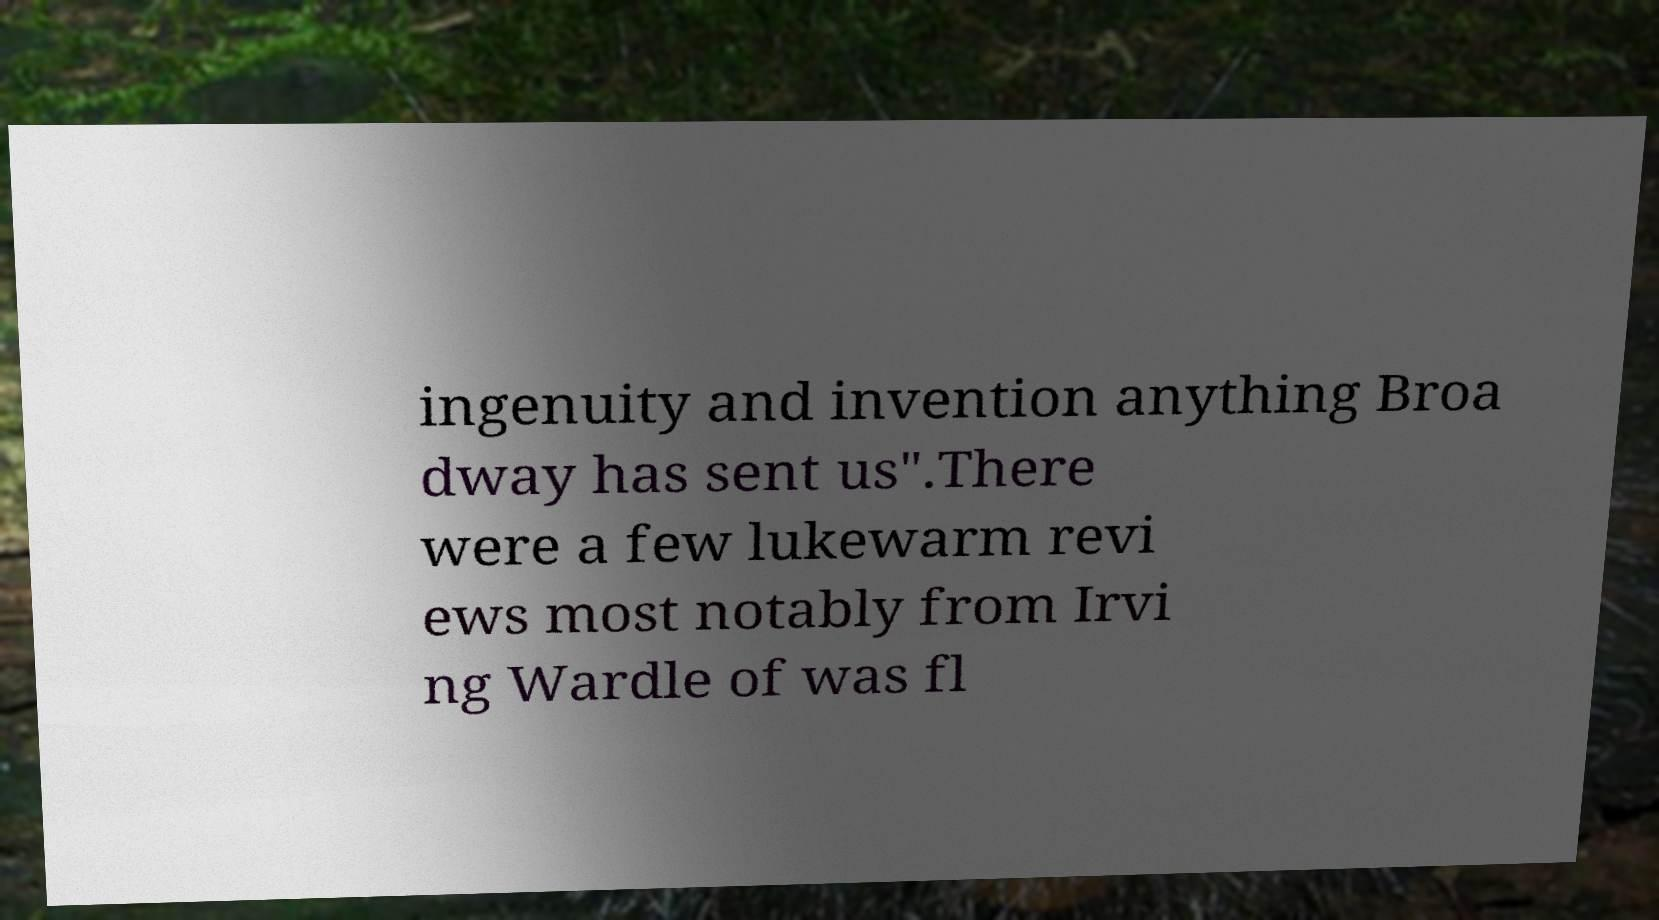I need the written content from this picture converted into text. Can you do that? ingenuity and invention anything Broa dway has sent us".There were a few lukewarm revi ews most notably from Irvi ng Wardle of was fl 